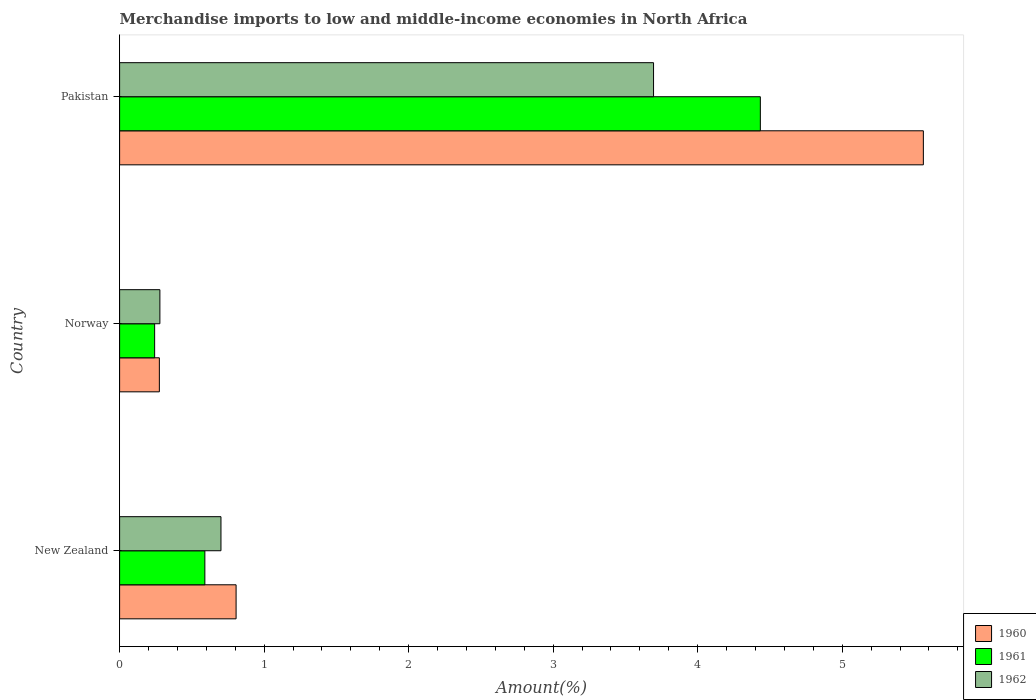How many different coloured bars are there?
Your answer should be compact. 3. How many groups of bars are there?
Offer a terse response. 3. What is the label of the 3rd group of bars from the top?
Your answer should be very brief. New Zealand. What is the percentage of amount earned from merchandise imports in 1962 in Norway?
Ensure brevity in your answer.  0.28. Across all countries, what is the maximum percentage of amount earned from merchandise imports in 1962?
Keep it short and to the point. 3.69. Across all countries, what is the minimum percentage of amount earned from merchandise imports in 1960?
Ensure brevity in your answer.  0.28. In which country was the percentage of amount earned from merchandise imports in 1961 maximum?
Provide a succinct answer. Pakistan. What is the total percentage of amount earned from merchandise imports in 1961 in the graph?
Your response must be concise. 5.27. What is the difference between the percentage of amount earned from merchandise imports in 1960 in New Zealand and that in Norway?
Give a very brief answer. 0.53. What is the difference between the percentage of amount earned from merchandise imports in 1961 in Pakistan and the percentage of amount earned from merchandise imports in 1962 in Norway?
Your answer should be compact. 4.15. What is the average percentage of amount earned from merchandise imports in 1960 per country?
Make the answer very short. 2.21. What is the difference between the percentage of amount earned from merchandise imports in 1962 and percentage of amount earned from merchandise imports in 1961 in Pakistan?
Offer a terse response. -0.74. In how many countries, is the percentage of amount earned from merchandise imports in 1960 greater than 4.8 %?
Offer a very short reply. 1. What is the ratio of the percentage of amount earned from merchandise imports in 1961 in New Zealand to that in Norway?
Provide a short and direct response. 2.43. Is the percentage of amount earned from merchandise imports in 1962 in New Zealand less than that in Pakistan?
Your answer should be very brief. Yes. Is the difference between the percentage of amount earned from merchandise imports in 1962 in Norway and Pakistan greater than the difference between the percentage of amount earned from merchandise imports in 1961 in Norway and Pakistan?
Your answer should be compact. Yes. What is the difference between the highest and the second highest percentage of amount earned from merchandise imports in 1960?
Offer a very short reply. 4.76. What is the difference between the highest and the lowest percentage of amount earned from merchandise imports in 1962?
Ensure brevity in your answer.  3.42. In how many countries, is the percentage of amount earned from merchandise imports in 1962 greater than the average percentage of amount earned from merchandise imports in 1962 taken over all countries?
Your response must be concise. 1. Is it the case that in every country, the sum of the percentage of amount earned from merchandise imports in 1961 and percentage of amount earned from merchandise imports in 1962 is greater than the percentage of amount earned from merchandise imports in 1960?
Offer a very short reply. Yes. How many bars are there?
Your answer should be very brief. 9. How many countries are there in the graph?
Offer a very short reply. 3. What is the difference between two consecutive major ticks on the X-axis?
Your response must be concise. 1. Does the graph contain grids?
Your answer should be compact. No. How are the legend labels stacked?
Keep it short and to the point. Vertical. What is the title of the graph?
Keep it short and to the point. Merchandise imports to low and middle-income economies in North Africa. What is the label or title of the X-axis?
Offer a very short reply. Amount(%). What is the Amount(%) in 1960 in New Zealand?
Offer a terse response. 0.81. What is the Amount(%) of 1961 in New Zealand?
Your response must be concise. 0.59. What is the Amount(%) in 1962 in New Zealand?
Offer a terse response. 0.7. What is the Amount(%) of 1960 in Norway?
Your answer should be compact. 0.28. What is the Amount(%) of 1961 in Norway?
Your answer should be compact. 0.24. What is the Amount(%) of 1962 in Norway?
Your answer should be compact. 0.28. What is the Amount(%) of 1960 in Pakistan?
Provide a short and direct response. 5.56. What is the Amount(%) in 1961 in Pakistan?
Make the answer very short. 4.43. What is the Amount(%) in 1962 in Pakistan?
Offer a terse response. 3.69. Across all countries, what is the maximum Amount(%) in 1960?
Your answer should be very brief. 5.56. Across all countries, what is the maximum Amount(%) in 1961?
Make the answer very short. 4.43. Across all countries, what is the maximum Amount(%) in 1962?
Your response must be concise. 3.69. Across all countries, what is the minimum Amount(%) of 1960?
Make the answer very short. 0.28. Across all countries, what is the minimum Amount(%) of 1961?
Provide a succinct answer. 0.24. Across all countries, what is the minimum Amount(%) in 1962?
Offer a very short reply. 0.28. What is the total Amount(%) in 1960 in the graph?
Your response must be concise. 6.64. What is the total Amount(%) in 1961 in the graph?
Your answer should be compact. 5.27. What is the total Amount(%) of 1962 in the graph?
Give a very brief answer. 4.67. What is the difference between the Amount(%) of 1960 in New Zealand and that in Norway?
Ensure brevity in your answer.  0.53. What is the difference between the Amount(%) in 1961 in New Zealand and that in Norway?
Provide a succinct answer. 0.35. What is the difference between the Amount(%) in 1962 in New Zealand and that in Norway?
Provide a short and direct response. 0.42. What is the difference between the Amount(%) in 1960 in New Zealand and that in Pakistan?
Ensure brevity in your answer.  -4.76. What is the difference between the Amount(%) of 1961 in New Zealand and that in Pakistan?
Offer a very short reply. -3.84. What is the difference between the Amount(%) of 1962 in New Zealand and that in Pakistan?
Your answer should be compact. -2.99. What is the difference between the Amount(%) in 1960 in Norway and that in Pakistan?
Offer a very short reply. -5.29. What is the difference between the Amount(%) of 1961 in Norway and that in Pakistan?
Your answer should be very brief. -4.19. What is the difference between the Amount(%) in 1962 in Norway and that in Pakistan?
Keep it short and to the point. -3.42. What is the difference between the Amount(%) of 1960 in New Zealand and the Amount(%) of 1961 in Norway?
Offer a terse response. 0.56. What is the difference between the Amount(%) in 1960 in New Zealand and the Amount(%) in 1962 in Norway?
Ensure brevity in your answer.  0.53. What is the difference between the Amount(%) in 1961 in New Zealand and the Amount(%) in 1962 in Norway?
Offer a very short reply. 0.31. What is the difference between the Amount(%) of 1960 in New Zealand and the Amount(%) of 1961 in Pakistan?
Offer a terse response. -3.63. What is the difference between the Amount(%) of 1960 in New Zealand and the Amount(%) of 1962 in Pakistan?
Give a very brief answer. -2.89. What is the difference between the Amount(%) of 1961 in New Zealand and the Amount(%) of 1962 in Pakistan?
Ensure brevity in your answer.  -3.1. What is the difference between the Amount(%) of 1960 in Norway and the Amount(%) of 1961 in Pakistan?
Offer a very short reply. -4.16. What is the difference between the Amount(%) of 1960 in Norway and the Amount(%) of 1962 in Pakistan?
Make the answer very short. -3.42. What is the difference between the Amount(%) of 1961 in Norway and the Amount(%) of 1962 in Pakistan?
Your answer should be very brief. -3.45. What is the average Amount(%) of 1960 per country?
Make the answer very short. 2.21. What is the average Amount(%) in 1961 per country?
Provide a succinct answer. 1.76. What is the average Amount(%) of 1962 per country?
Keep it short and to the point. 1.56. What is the difference between the Amount(%) of 1960 and Amount(%) of 1961 in New Zealand?
Provide a short and direct response. 0.22. What is the difference between the Amount(%) of 1960 and Amount(%) of 1962 in New Zealand?
Your answer should be compact. 0.1. What is the difference between the Amount(%) in 1961 and Amount(%) in 1962 in New Zealand?
Provide a short and direct response. -0.11. What is the difference between the Amount(%) of 1960 and Amount(%) of 1961 in Norway?
Keep it short and to the point. 0.03. What is the difference between the Amount(%) in 1960 and Amount(%) in 1962 in Norway?
Provide a succinct answer. -0. What is the difference between the Amount(%) of 1961 and Amount(%) of 1962 in Norway?
Provide a short and direct response. -0.04. What is the difference between the Amount(%) in 1960 and Amount(%) in 1961 in Pakistan?
Provide a short and direct response. 1.13. What is the difference between the Amount(%) in 1960 and Amount(%) in 1962 in Pakistan?
Provide a short and direct response. 1.87. What is the difference between the Amount(%) in 1961 and Amount(%) in 1962 in Pakistan?
Provide a succinct answer. 0.74. What is the ratio of the Amount(%) in 1960 in New Zealand to that in Norway?
Your answer should be compact. 2.93. What is the ratio of the Amount(%) in 1961 in New Zealand to that in Norway?
Your answer should be compact. 2.43. What is the ratio of the Amount(%) in 1962 in New Zealand to that in Norway?
Give a very brief answer. 2.52. What is the ratio of the Amount(%) in 1960 in New Zealand to that in Pakistan?
Provide a succinct answer. 0.14. What is the ratio of the Amount(%) of 1961 in New Zealand to that in Pakistan?
Ensure brevity in your answer.  0.13. What is the ratio of the Amount(%) of 1962 in New Zealand to that in Pakistan?
Make the answer very short. 0.19. What is the ratio of the Amount(%) in 1960 in Norway to that in Pakistan?
Offer a very short reply. 0.05. What is the ratio of the Amount(%) of 1961 in Norway to that in Pakistan?
Your response must be concise. 0.05. What is the ratio of the Amount(%) of 1962 in Norway to that in Pakistan?
Your answer should be very brief. 0.08. What is the difference between the highest and the second highest Amount(%) in 1960?
Keep it short and to the point. 4.76. What is the difference between the highest and the second highest Amount(%) of 1961?
Your answer should be compact. 3.84. What is the difference between the highest and the second highest Amount(%) in 1962?
Provide a succinct answer. 2.99. What is the difference between the highest and the lowest Amount(%) in 1960?
Keep it short and to the point. 5.29. What is the difference between the highest and the lowest Amount(%) in 1961?
Provide a short and direct response. 4.19. What is the difference between the highest and the lowest Amount(%) in 1962?
Give a very brief answer. 3.42. 